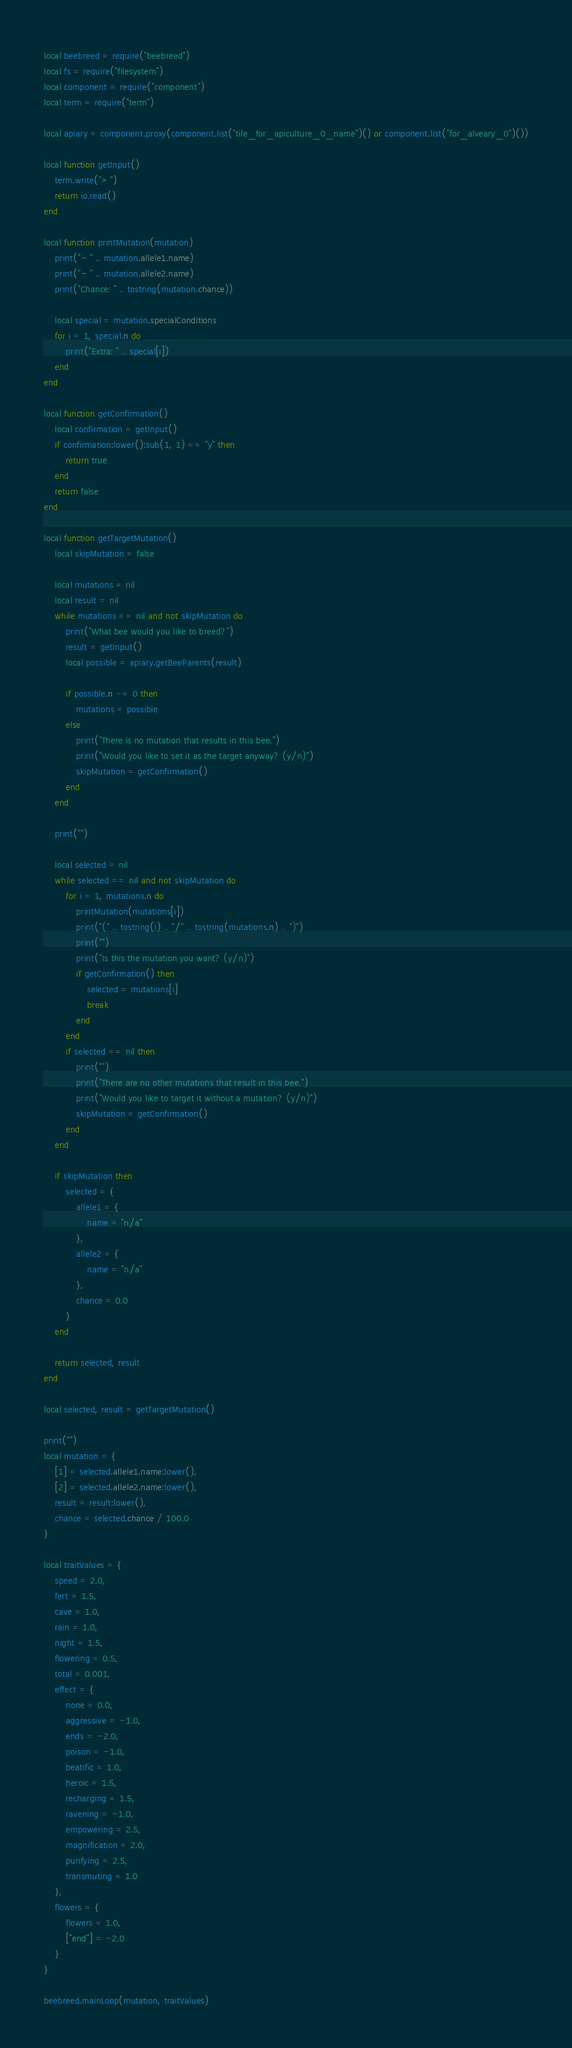<code> <loc_0><loc_0><loc_500><loc_500><_Lua_>local beebreed = require("beebreed")
local fs = require("filesystem")
local component = require("component")
local term = require("term")

local apiary = component.proxy(component.list("tile_for_apiculture_0_name")() or component.list("for_alveary_0")())

local function getInput()
    term.write("> ")
    return io.read()
end

local function printMutation(mutation)
    print("- " .. mutation.allele1.name)
    print("- " .. mutation.allele2.name)
    print("Chance: " .. tostring(mutation.chance))

    local special = mutation.specialConditions
    for i = 1, special.n do
        print("Extra: " .. special[i])
    end
end

local function getConfirmation()
    local confirmation = getInput()
    if confirmation:lower():sub(1, 1) == "y" then
        return true
    end
    return false
end

local function getTargetMutation()
    local skipMutation = false

    local mutations = nil
    local result = nil
    while mutations == nil and not skipMutation do
        print("What bee would you like to breed?")
        result = getInput()
        local possible = apiary.getBeeParents(result)
    
        if possible.n ~= 0 then
            mutations = possible
        else
            print("There is no mutation that results in this bee.")
            print("Would you like to set it as the target anyway? (y/n)")
            skipMutation = getConfirmation()
        end
    end
    
    print("")
    
    local selected = nil
    while selected == nil and not skipMutation do
        for i = 1, mutations.n do
            printMutation(mutations[i])
            print("(" .. tostring(i) .. "/" .. tostring(mutations.n) .. ")")
            print("")
            print("Is this the mutation you want? (y/n)")
            if getConfirmation() then
                selected = mutations[i]
                break
            end
        end
        if selected == nil then
            print("")
            print("There are no other mutations that result in this bee.")
            print("Would you like to target it without a mutation? (y/n)")
            skipMutation = getConfirmation()
        end
    end

    if skipMutation then
        selected = {
            allele1 = {
                name = "n/a"
            },
            allele2 = {
                name = "n/a"
            },
            chance = 0.0
        }
    end

    return selected, result
end

local selected, result = getTargetMutation()

print("")
local mutation = {
    [1] = selected.allele1.name:lower(),
    [2] = selected.allele2.name:lower(),
    result = result:lower(),
    chance = selected.chance / 100.0
}

local traitValues = {
    speed = 2.0,
    fert = 1.5,
    cave = 1.0,
    rain = 1.0,
    night = 1.5,
    flowering = 0.5,
    total = 0.001,
    effect = {
        none = 0.0,
        aggressive = -1.0,
        ends = -2.0,
        poison = -1.0,
        beatific = 1.0,
        heroic = 1.5,
        recharging = 1.5,
        ravening = -1.0,
        empowering = 2.5,
        magnification = 2.0,
        purifying = 2.5,
        transmuting = 1.0
    },
    flowers = {
        flowers = 1.0,
        ["end"] = -2.0
    }
}

beebreed.mainLoop(mutation, traitValues)</code> 